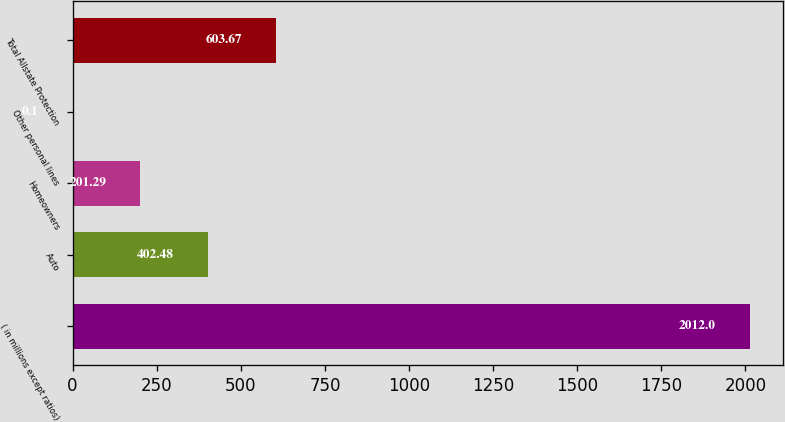Convert chart to OTSL. <chart><loc_0><loc_0><loc_500><loc_500><bar_chart><fcel>( in millions except ratios)<fcel>Auto<fcel>Homeowners<fcel>Other personal lines<fcel>Total Allstate Protection<nl><fcel>2012<fcel>402.48<fcel>201.29<fcel>0.1<fcel>603.67<nl></chart> 